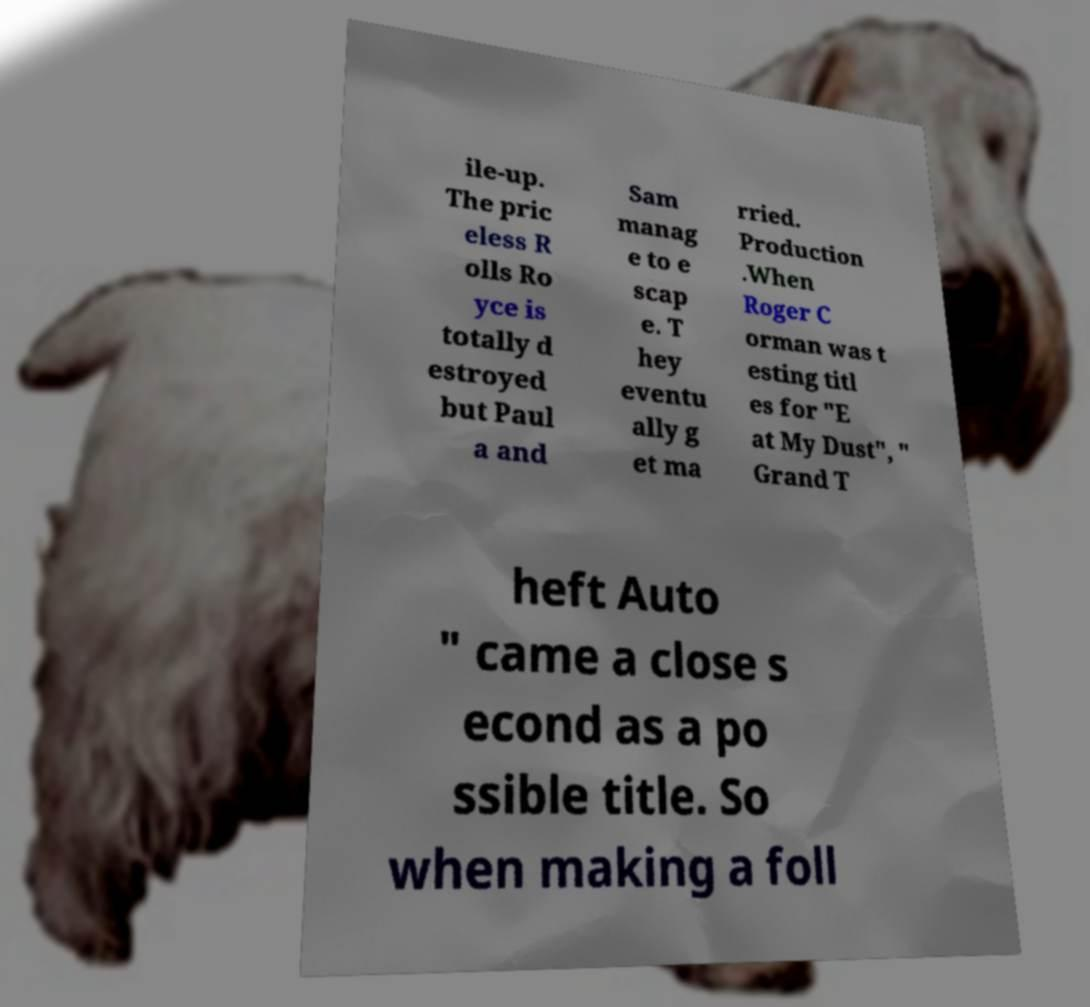Please read and relay the text visible in this image. What does it say? ile-up. The pric eless R olls Ro yce is totally d estroyed but Paul a and Sam manag e to e scap e. T hey eventu ally g et ma rried. Production .When Roger C orman was t esting titl es for "E at My Dust", " Grand T heft Auto " came a close s econd as a po ssible title. So when making a foll 